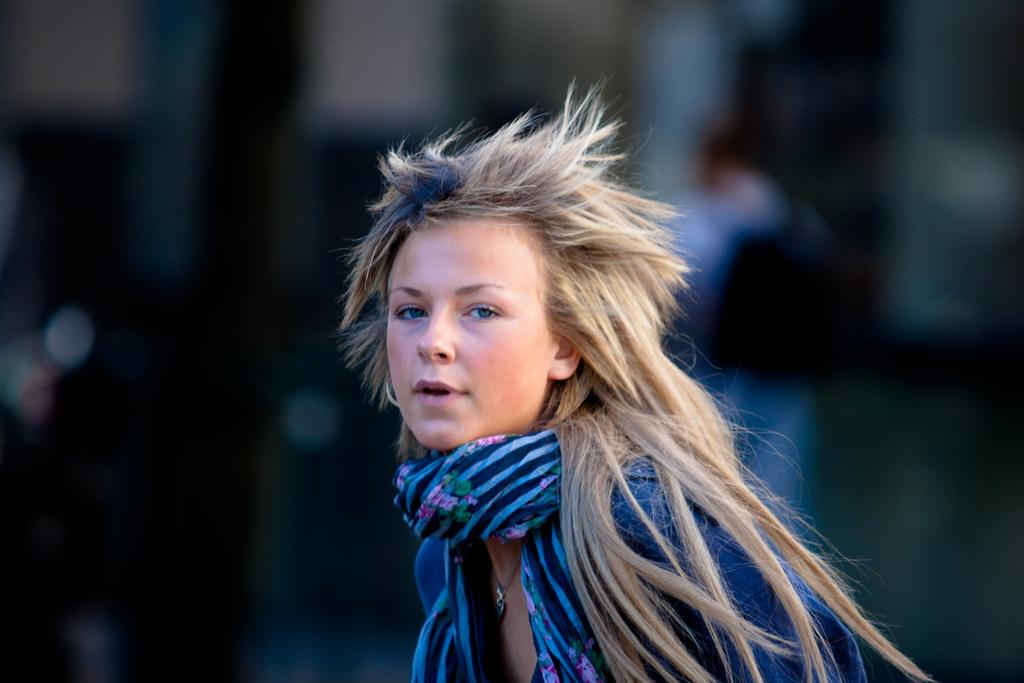Who is the main subject in the image? There is a lady in the image. Can you describe the background of the image? The background of the image is blurry. What is the lady's reaction to the sudden turn in the image? There is no sudden turn or any indication of a reaction in the image. 